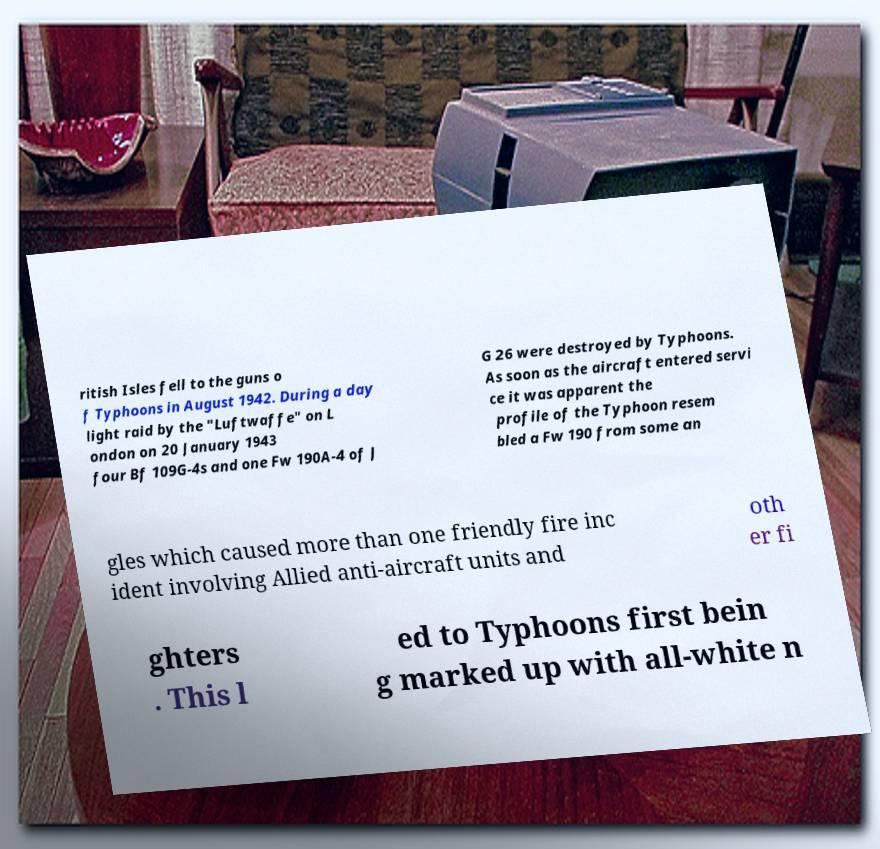Could you extract and type out the text from this image? ritish Isles fell to the guns o f Typhoons in August 1942. During a day light raid by the "Luftwaffe" on L ondon on 20 January 1943 four Bf 109G-4s and one Fw 190A-4 of J G 26 were destroyed by Typhoons. As soon as the aircraft entered servi ce it was apparent the profile of the Typhoon resem bled a Fw 190 from some an gles which caused more than one friendly fire inc ident involving Allied anti-aircraft units and oth er fi ghters . This l ed to Typhoons first bein g marked up with all-white n 